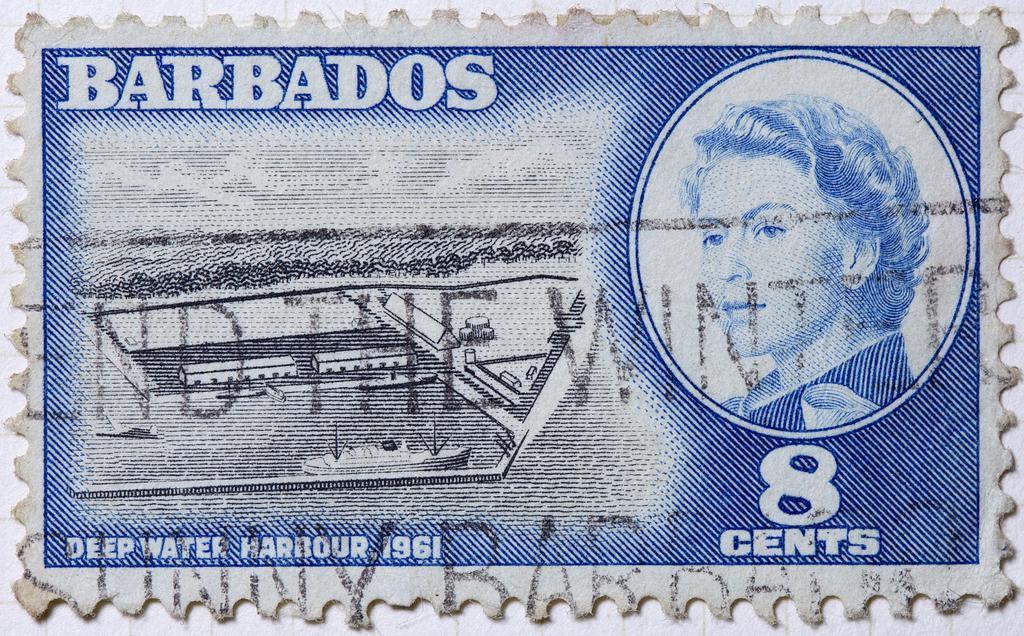Can you describe this image briefly? This is the picture of a currency on which there is a picture of a person and some things written around. 